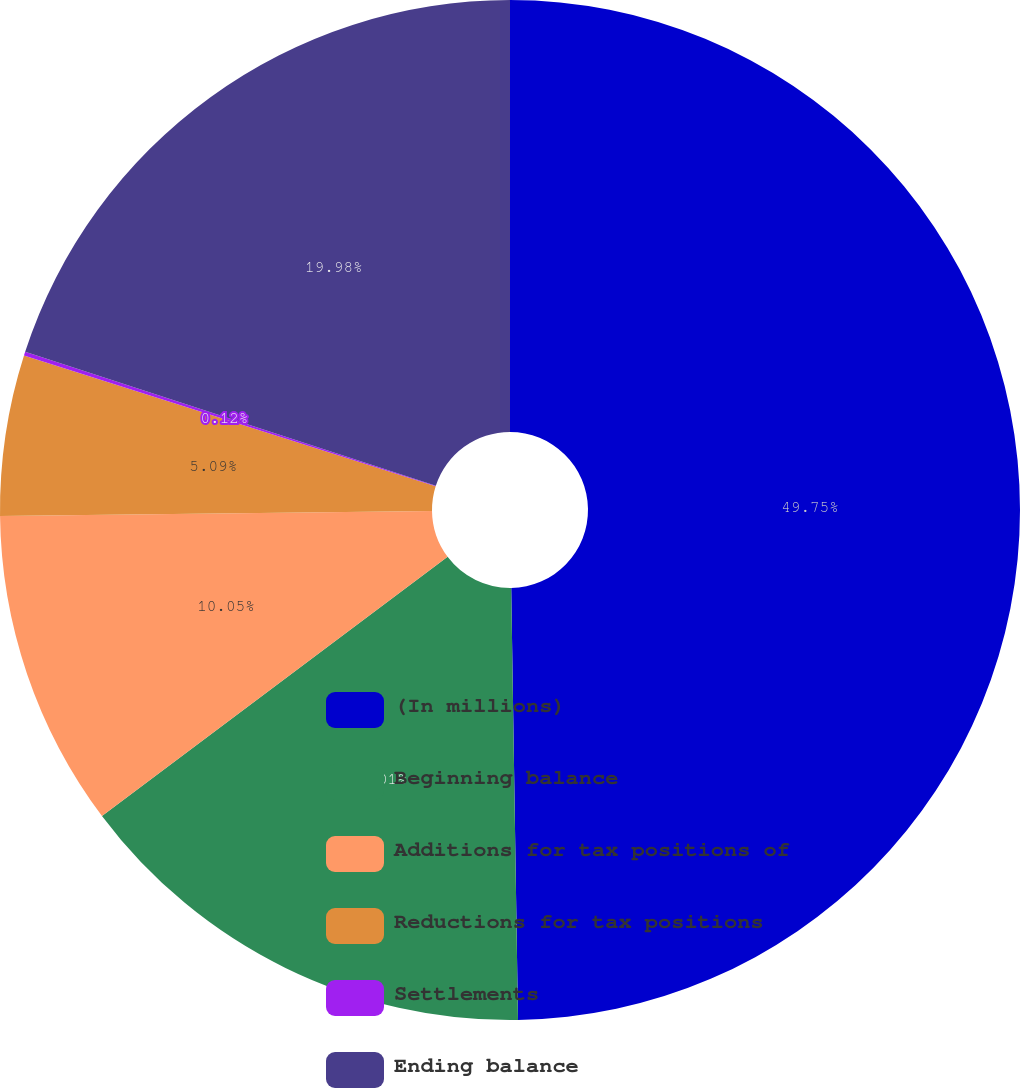<chart> <loc_0><loc_0><loc_500><loc_500><pie_chart><fcel>(In millions)<fcel>Beginning balance<fcel>Additions for tax positions of<fcel>Reductions for tax positions<fcel>Settlements<fcel>Ending balance<nl><fcel>49.75%<fcel>15.01%<fcel>10.05%<fcel>5.09%<fcel>0.12%<fcel>19.98%<nl></chart> 